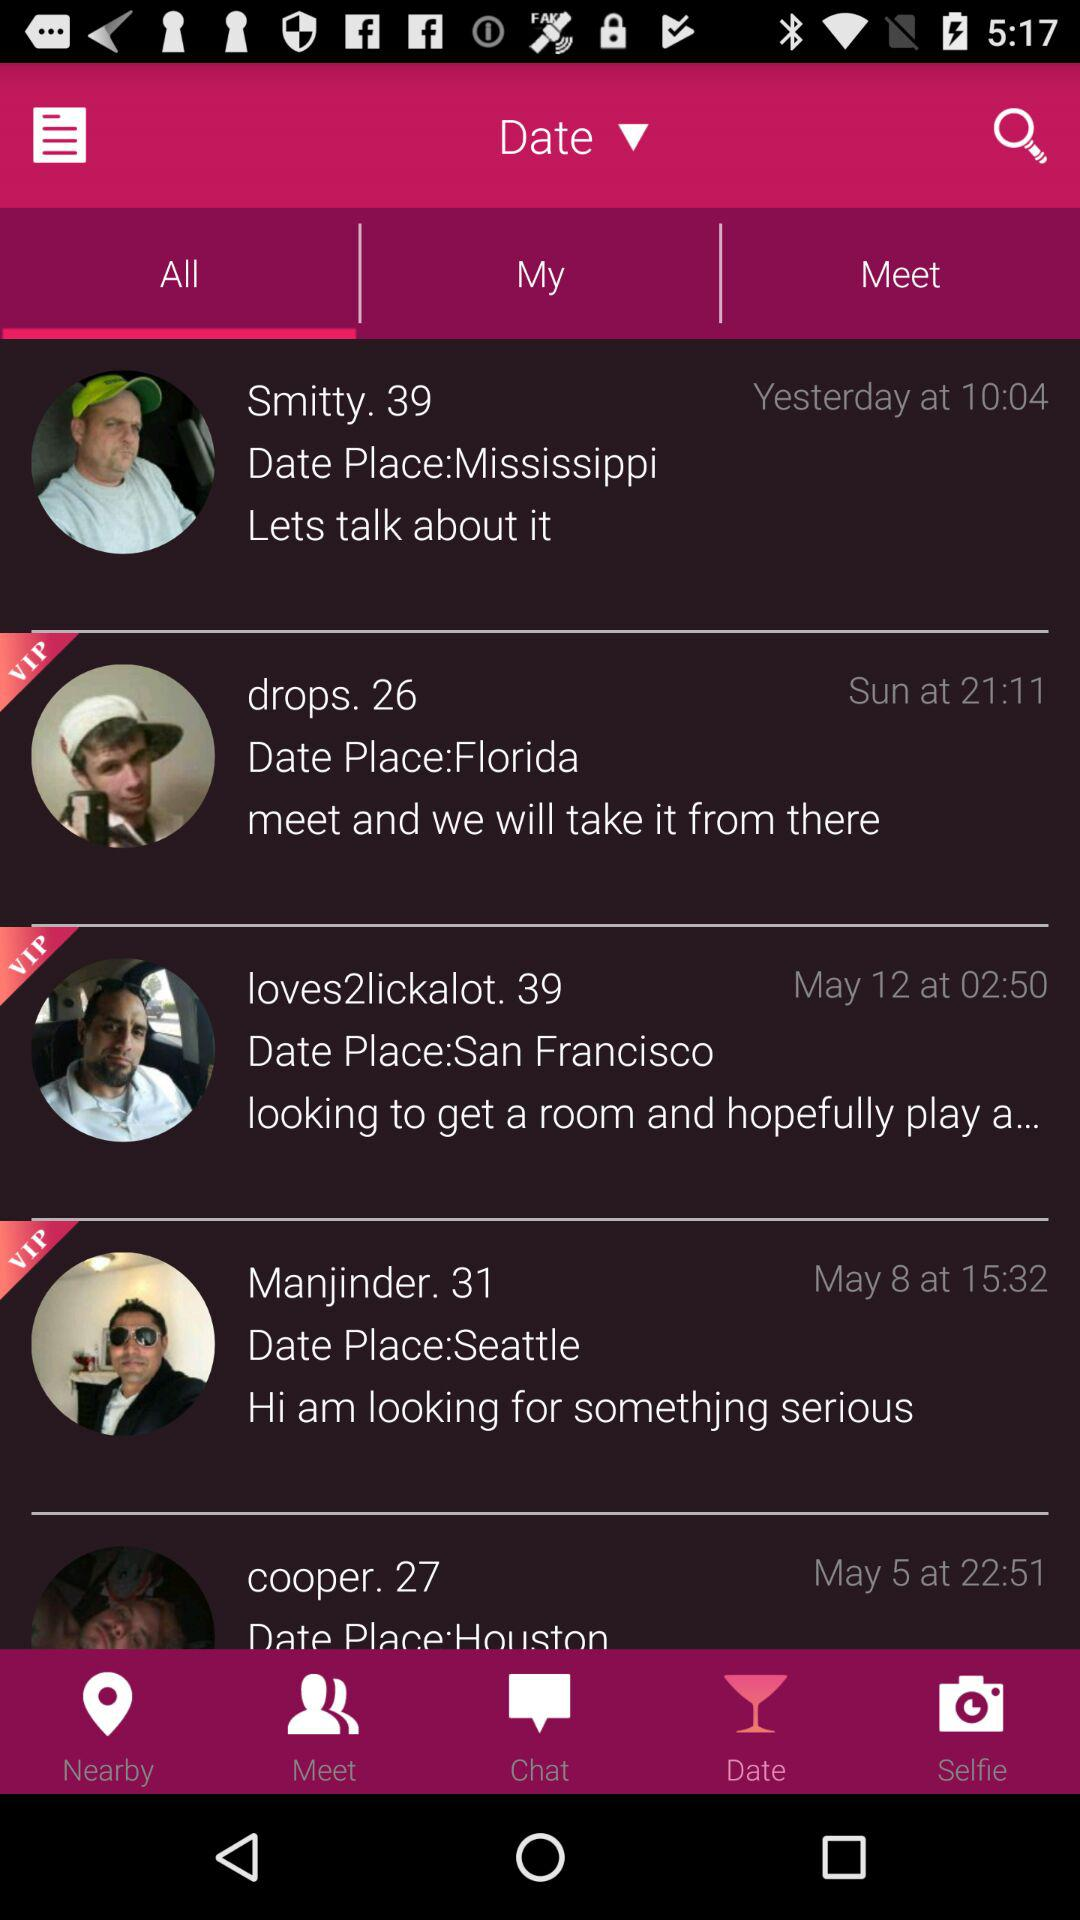Which tab is selected? The selected tabs are "Date" and "All". 